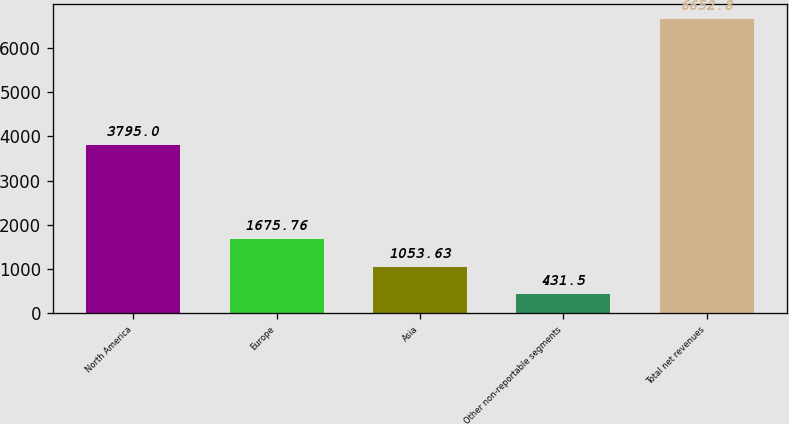Convert chart. <chart><loc_0><loc_0><loc_500><loc_500><bar_chart><fcel>North America<fcel>Europe<fcel>Asia<fcel>Other non-reportable segments<fcel>Total net revenues<nl><fcel>3795<fcel>1675.76<fcel>1053.63<fcel>431.5<fcel>6652.8<nl></chart> 